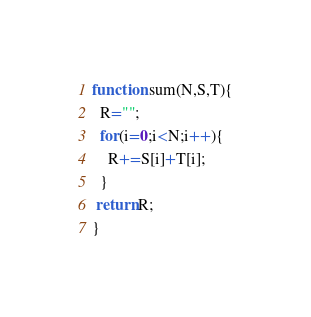Convert code to text. <code><loc_0><loc_0><loc_500><loc_500><_JavaScript_>function sum(N,S,T){
  R="";
  for(i=0;i<N;i++){
    R+=S[i]+T[i];
  }
 return R;
}</code> 